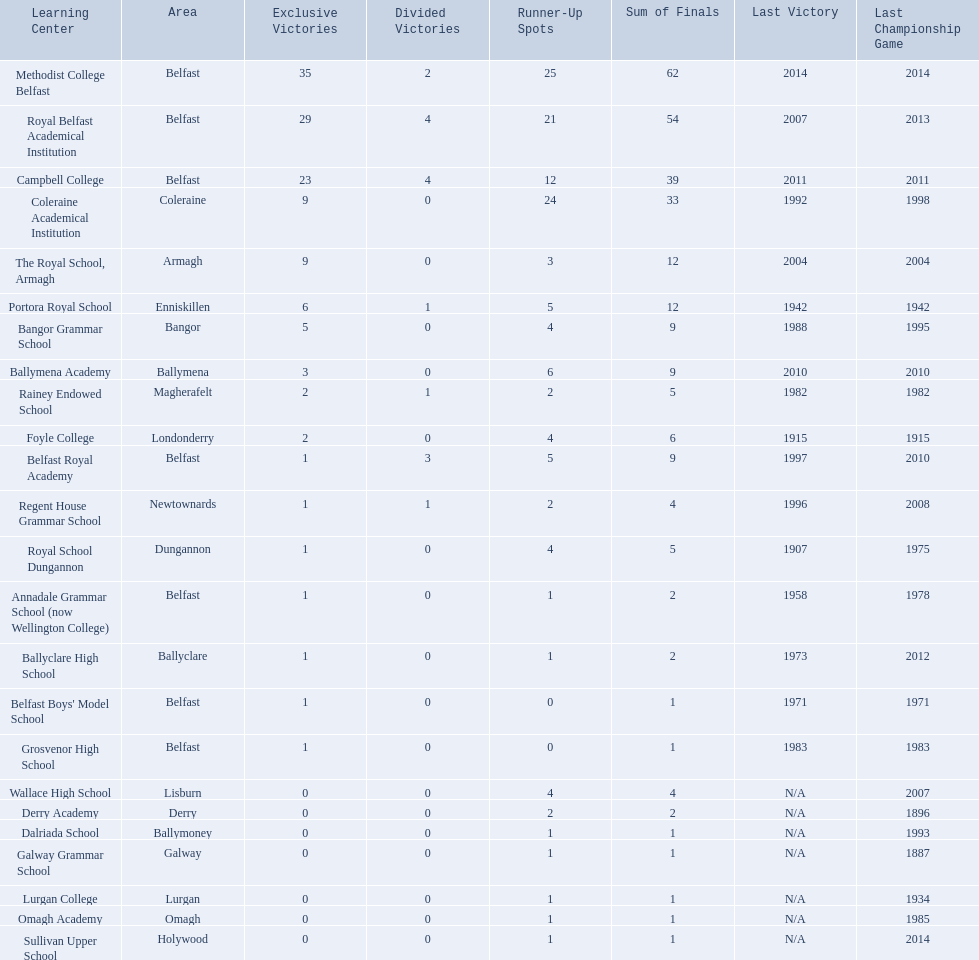What is the most recent win of campbell college? 2011. What is the most recent win of regent house grammar school? 1996. Which date is more recent? 2011. What is the name of the school with this date? Campbell College. 